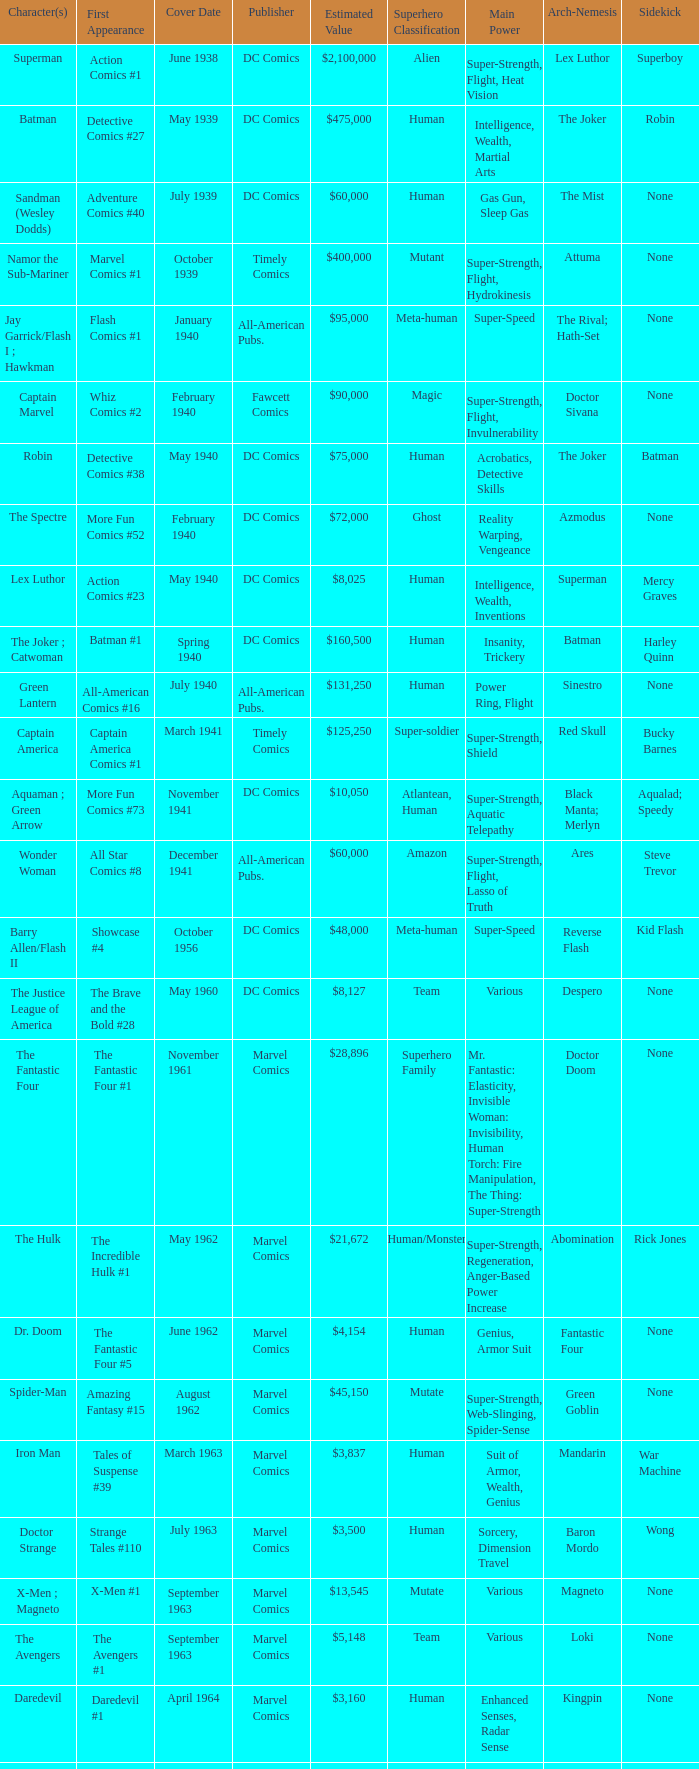Who publishes Wolverine? Marvel Comics. 